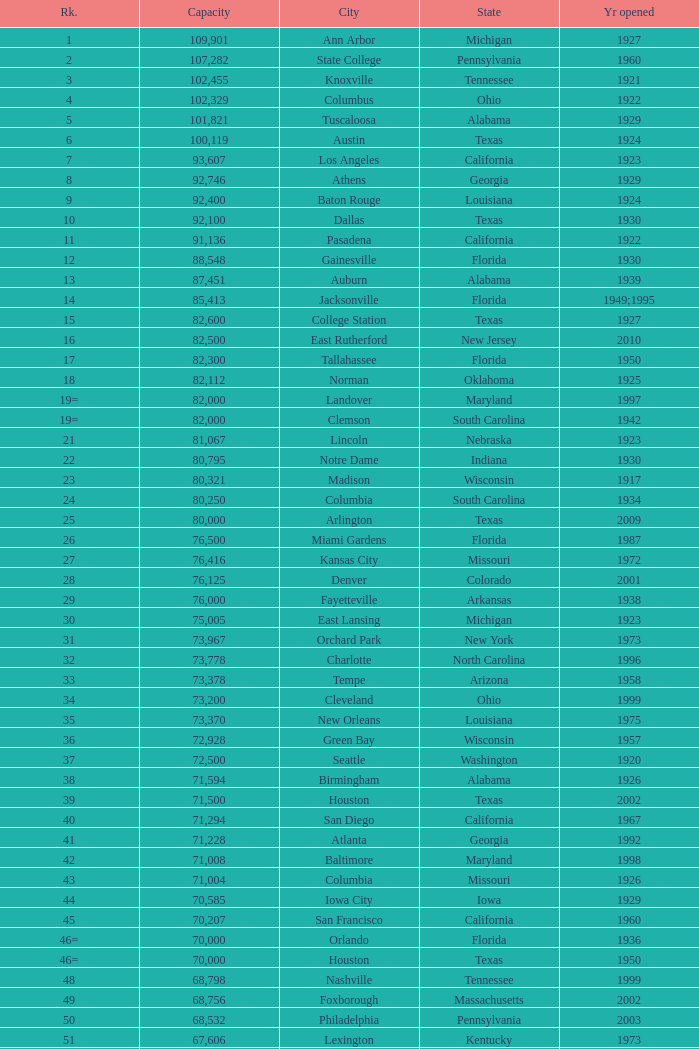Could you parse the entire table? {'header': ['Rk.', 'Capacity', 'City', 'State', 'Yr opened'], 'rows': [['1', '109,901', 'Ann Arbor', 'Michigan', '1927'], ['2', '107,282', 'State College', 'Pennsylvania', '1960'], ['3', '102,455', 'Knoxville', 'Tennessee', '1921'], ['4', '102,329', 'Columbus', 'Ohio', '1922'], ['5', '101,821', 'Tuscaloosa', 'Alabama', '1929'], ['6', '100,119', 'Austin', 'Texas', '1924'], ['7', '93,607', 'Los Angeles', 'California', '1923'], ['8', '92,746', 'Athens', 'Georgia', '1929'], ['9', '92,400', 'Baton Rouge', 'Louisiana', '1924'], ['10', '92,100', 'Dallas', 'Texas', '1930'], ['11', '91,136', 'Pasadena', 'California', '1922'], ['12', '88,548', 'Gainesville', 'Florida', '1930'], ['13', '87,451', 'Auburn', 'Alabama', '1939'], ['14', '85,413', 'Jacksonville', 'Florida', '1949;1995'], ['15', '82,600', 'College Station', 'Texas', '1927'], ['16', '82,500', 'East Rutherford', 'New Jersey', '2010'], ['17', '82,300', 'Tallahassee', 'Florida', '1950'], ['18', '82,112', 'Norman', 'Oklahoma', '1925'], ['19=', '82,000', 'Landover', 'Maryland', '1997'], ['19=', '82,000', 'Clemson', 'South Carolina', '1942'], ['21', '81,067', 'Lincoln', 'Nebraska', '1923'], ['22', '80,795', 'Notre Dame', 'Indiana', '1930'], ['23', '80,321', 'Madison', 'Wisconsin', '1917'], ['24', '80,250', 'Columbia', 'South Carolina', '1934'], ['25', '80,000', 'Arlington', 'Texas', '2009'], ['26', '76,500', 'Miami Gardens', 'Florida', '1987'], ['27', '76,416', 'Kansas City', 'Missouri', '1972'], ['28', '76,125', 'Denver', 'Colorado', '2001'], ['29', '76,000', 'Fayetteville', 'Arkansas', '1938'], ['30', '75,005', 'East Lansing', 'Michigan', '1923'], ['31', '73,967', 'Orchard Park', 'New York', '1973'], ['32', '73,778', 'Charlotte', 'North Carolina', '1996'], ['33', '73,378', 'Tempe', 'Arizona', '1958'], ['34', '73,200', 'Cleveland', 'Ohio', '1999'], ['35', '73,370', 'New Orleans', 'Louisiana', '1975'], ['36', '72,928', 'Green Bay', 'Wisconsin', '1957'], ['37', '72,500', 'Seattle', 'Washington', '1920'], ['38', '71,594', 'Birmingham', 'Alabama', '1926'], ['39', '71,500', 'Houston', 'Texas', '2002'], ['40', '71,294', 'San Diego', 'California', '1967'], ['41', '71,228', 'Atlanta', 'Georgia', '1992'], ['42', '71,008', 'Baltimore', 'Maryland', '1998'], ['43', '71,004', 'Columbia', 'Missouri', '1926'], ['44', '70,585', 'Iowa City', 'Iowa', '1929'], ['45', '70,207', 'San Francisco', 'California', '1960'], ['46=', '70,000', 'Orlando', 'Florida', '1936'], ['46=', '70,000', 'Houston', 'Texas', '1950'], ['48', '68,798', 'Nashville', 'Tennessee', '1999'], ['49', '68,756', 'Foxborough', 'Massachusetts', '2002'], ['50', '68,532', 'Philadelphia', 'Pennsylvania', '2003'], ['51', '67,606', 'Lexington', 'Kentucky', '1973'], ['52', '67,000', 'Seattle', 'Washington', '2002'], ['53', '66,965', 'St. Louis', 'Missouri', '1995'], ['54', '66,233', 'Blacksburg', 'Virginia', '1965'], ['55', '65,857', 'Tampa', 'Florida', '1998'], ['56', '65,790', 'Cincinnati', 'Ohio', '2000'], ['57', '65,050', 'Pittsburgh', 'Pennsylvania', '2001'], ['58=', '65,000', 'San Antonio', 'Texas', '1993'], ['58=', '65,000', 'Detroit', 'Michigan', '2002'], ['60', '64,269', 'New Haven', 'Connecticut', '1914'], ['61', '64,111', 'Minneapolis', 'Minnesota', '1982'], ['62', '64,045', 'Provo', 'Utah', '1964'], ['63', '63,400', 'Glendale', 'Arizona', '2006'], ['64', '63,026', 'Oakland', 'California', '1966'], ['65', '63,000', 'Indianapolis', 'Indiana', '2008'], ['65', '63.000', 'Chapel Hill', 'North Carolina', '1926'], ['66', '62,872', 'Champaign', 'Illinois', '1923'], ['67', '62,717', 'Berkeley', 'California', '1923'], ['68', '61,500', 'Chicago', 'Illinois', '1924;2003'], ['69', '62,500', 'West Lafayette', 'Indiana', '1924'], ['70', '62,380', 'Memphis', 'Tennessee', '1965'], ['71', '61,500', 'Charlottesville', 'Virginia', '1931'], ['72', '61,000', 'Lubbock', 'Texas', '1947'], ['73', '60,580', 'Oxford', 'Mississippi', '1915'], ['74', '60,540', 'Morgantown', 'West Virginia', '1980'], ['75', '60,492', 'Jackson', 'Mississippi', '1941'], ['76', '60,000', 'Stillwater', 'Oklahoma', '1920'], ['78', '57,803', 'Tucson', 'Arizona', '1928'], ['79', '57,583', 'Raleigh', 'North Carolina', '1966'], ['80', '56,692', 'Washington, D.C.', 'District of Columbia', '1961'], ['81=', '56,000', 'Los Angeles', 'California', '1962'], ['81=', '56,000', 'Louisville', 'Kentucky', '1998'], ['83', '55,082', 'Starkville', 'Mississippi', '1914'], ['84=', '55,000', 'Atlanta', 'Georgia', '1913'], ['84=', '55,000', 'Ames', 'Iowa', '1975'], ['86', '53,800', 'Eugene', 'Oregon', '1967'], ['87', '53,750', 'Boulder', 'Colorado', '1924'], ['88', '53,727', 'Little Rock', 'Arkansas', '1948'], ['89', '53,500', 'Bloomington', 'Indiana', '1960'], ['90', '52,593', 'Philadelphia', 'Pennsylvania', '1895'], ['91', '52,480', 'Colorado Springs', 'Colorado', '1962'], ['92', '52,454', 'Piscataway', 'New Jersey', '1994'], ['93', '52,200', 'Manhattan', 'Kansas', '1968'], ['94=', '51,500', 'College Park', 'Maryland', '1950'], ['94=', '51,500', 'El Paso', 'Texas', '1963'], ['96', '50,832', 'Shreveport', 'Louisiana', '1925'], ['97', '50,805', 'Minneapolis', 'Minnesota', '2009'], ['98', '50,445', 'Denver', 'Colorado', '1995'], ['99', '50,291', 'Bronx', 'New York', '2009'], ['100', '50,096', 'Atlanta', 'Georgia', '1996'], ['101', '50,071', 'Lawrence', 'Kansas', '1921'], ['102=', '50,000', 'Honolulu', 'Hawai ʻ i', '1975'], ['102=', '50,000', 'Greenville', 'North Carolina', '1963'], ['102=', '50,000', 'Waco', 'Texas', '1950'], ['102=', '50,000', 'Stanford', 'California', '1921;2006'], ['106', '49,262', 'Syracuse', 'New York', '1980'], ['107', '49,115', 'Arlington', 'Texas', '1994'], ['108', '49,033', 'Phoenix', 'Arizona', '1998'], ['109', '48,876', 'Baltimore', 'Maryland', '1992'], ['110', '47,130', 'Evanston', 'Illinois', '1996'], ['111', '47,116', 'Seattle', 'Washington', '1999'], ['112', '46,861', 'St. Louis', 'Missouri', '2006'], ['113', '45,674', 'Corvallis', 'Oregon', '1953'], ['114', '45,634', 'Salt Lake City', 'Utah', '1998'], ['115', '45,301', 'Orlando', 'Florida', '2007'], ['116', '45,050', 'Anaheim', 'California', '1966'], ['117', '44,500', 'Chestnut Hill', 'Massachusetts', '1957'], ['118', '44,008', 'Fort Worth', 'Texas', '1930'], ['119', '43,647', 'Philadelphia', 'Pennsylvania', '2004'], ['120', '43,545', 'Cleveland', 'Ohio', '1994'], ['121', '42,445', 'San Diego', 'California', '2004'], ['122', '42,059', 'Cincinnati', 'Ohio', '2003'], ['123', '41,900', 'Milwaukee', 'Wisconsin', '2001'], ['124', '41,888', 'Washington, D.C.', 'District of Columbia', '2008'], ['125', '41,800', 'Flushing, New York', 'New York', '2009'], ['126', '41,782', 'Detroit', 'Michigan', '2000'], ['127', '41,503', 'San Francisco', 'California', '2000'], ['128', '41,160', 'Chicago', 'Illinois', '1914'], ['129', '41,031', 'Fresno', 'California', '1980'], ['130', '40,950', 'Houston', 'Texas', '2000'], ['131', '40,646', 'Mobile', 'Alabama', '1948'], ['132', '40,615', 'Chicago', 'Illinois', '1991'], ['133', '40,094', 'Albuquerque', 'New Mexico', '1960'], ['134=', '40,000', 'South Williamsport', 'Pennsylvania', '1959'], ['134=', '40,000', 'East Hartford', 'Connecticut', '2003'], ['134=', '40,000', 'West Point', 'New York', '1924'], ['137', '39,790', 'Nashville', 'Tennessee', '1922'], ['138', '39,504', 'Minneapolis', 'Minnesota', '2010'], ['139', '39,000', 'Kansas City', 'Missouri', '1973'], ['140', '38,496', 'Pittsburgh', 'Pennsylvania', '2001'], ['141', '38,019', 'Huntington', 'West Virginia', '1991'], ['142', '37,402', 'Boston', 'Massachusetts', '1912'], ['143=', '37,000', 'Boise', 'Idaho', '1970'], ['143=', '37,000', 'Miami', 'Florida', '2012'], ['145', '36,973', 'St. Petersburg', 'Florida', '1990'], ['146', '36,800', 'Whitney', 'Nevada', '1971'], ['147', '36,000', 'Hattiesburg', 'Mississippi', '1932'], ['148', '35,117', 'Pullman', 'Washington', '1972'], ['149', '35,097', 'Cincinnati', 'Ohio', '1924'], ['150', '34,400', 'Fort Collins', 'Colorado', '1968'], ['151', '34,000', 'Annapolis', 'Maryland', '1959'], ['152', '33,941', 'Durham', 'North Carolina', '1929'], ['153', '32,580', 'Laramie', 'Wyoming', '1950'], ['154=', '32,000', 'University Park', 'Texas', '2000'], ['154=', '32,000', 'Houston', 'Texas', '1942'], ['156', '31,500', 'Winston-Salem', 'North Carolina', '1968'], ['157=', '31,000', 'Lafayette', 'Louisiana', '1971'], ['157=', '31,000', 'Akron', 'Ohio', '1940'], ['157=', '31,000', 'DeKalb', 'Illinois', '1965'], ['160', '30,964', 'Jonesboro', 'Arkansas', '1974'], ['161', '30,850', 'Denton', 'Texas', '2011'], ['162', '30,600', 'Ruston', 'Louisiana', '1960'], ['163', '30,456', 'San Jose', 'California', '1933'], ['164', '30,427', 'Monroe', 'Louisiana', '1978'], ['165', '30,343', 'Las Cruces', 'New Mexico', '1978'], ['166', '30,323', 'Allston', 'Massachusetts', '1903'], ['167', '30,295', 'Mount Pleasant', 'Michigan', '1972'], ['168=', '30,200', 'Ypsilanti', 'Michigan', '1969'], ['168=', '30,200', 'Kalamazoo', 'Michigan', '1939'], ['168=', '30,000', 'Boca Raton', 'Florida', '2011'], ['168=', '30,000', 'San Marcos', 'Texas', '1981'], ['168=', '30,000', 'Tulsa', 'Oklahoma', '1930'], ['168=', '30,000', 'Akron', 'Ohio', '2009'], ['168=', '30,000', 'Troy', 'Alabama', '1950'], ['168=', '30,000', 'Norfolk', 'Virginia', '1997'], ['176', '29,993', 'Reno', 'Nevada', '1966'], ['177', '29,013', 'Amherst', 'New York', '1993'], ['178', '29,000', 'Baton Rouge', 'Louisiana', '1928'], ['179', '28,646', 'Spokane', 'Washington', '1950'], ['180', '27,800', 'Princeton', 'New Jersey', '1998'], ['181', '27,000', 'Carson', 'California', '2003'], ['182', '26,248', 'Toledo', 'Ohio', '1937'], ['183', '25,600', 'Grambling', 'Louisiana', '1983'], ['184', '25,597', 'Ithaca', 'New York', '1915'], ['185', '25,500', 'Tallahassee', 'Florida', '1957'], ['186', '25,400', 'Muncie', 'Indiana', '1967'], ['187', '25,200', 'Missoula', 'Montana', '1986'], ['188', '25,189', 'Harrison', 'New Jersey', '2010'], ['189', '25,000', 'Kent', 'Ohio', '1969'], ['190', '24,877', 'Harrisonburg', 'Virginia', '1975'], ['191', '24,600', 'Montgomery', 'Alabama', '1922'], ['192', '24,286', 'Oxford', 'Ohio', '1983'], ['193=', '24,000', 'Omaha', 'Nebraska', '2011'], ['193=', '24,000', 'Athens', 'Ohio', '1929'], ['194', '23,724', 'Bowling Green', 'Ohio', '1966'], ['195', '23,500', 'Worcester', 'Massachusetts', '1924'], ['196', '22,500', 'Lorman', 'Mississippi', '1992'], ['197=', '22,000', 'Houston', 'Texas', '2012'], ['197=', '22,000', 'Newark', 'Delaware', '1952'], ['197=', '22,000', 'Bowling Green', 'Kentucky', '1968'], ['197=', '22,000', 'Orangeburg', 'South Carolina', '1955'], ['201', '21,650', 'Boone', 'North Carolina', '1962'], ['202', '21,500', 'Greensboro', 'North Carolina', '1981'], ['203', '21,650', 'Sacramento', 'California', '1969'], ['204=', '21,000', 'Charleston', 'South Carolina', '1946'], ['204=', '21,000', 'Huntsville', 'Alabama', '1996'], ['204=', '21,000', 'Chicago', 'Illinois', '1994'], ['207', '20,668', 'Chattanooga', 'Tennessee', '1997'], ['208', '20,630', 'Youngstown', 'Ohio', '1982'], ['209', '20,500', 'Frisco', 'Texas', '2005'], ['210', '20,455', 'Columbus', 'Ohio', '1999'], ['211', '20,450', 'Fort Lauderdale', 'Florida', '1959'], ['212', '20,438', 'Portland', 'Oregon', '1926'], ['213', '20,311', 'Sacramento, California', 'California', '1928'], ['214', '20,066', 'Detroit, Michigan', 'Michigan', '1979'], ['215', '20,008', 'Sandy', 'Utah', '2008'], ['216=', '20,000', 'Providence', 'Rhode Island', '1925'], ['216=', '20,000', 'Miami', 'Florida', '1995'], ['216=', '20,000', 'Richmond', 'Kentucky', '1969'], ['216=', '20,000', 'Mesquite', 'Texas', '1977'], ['216=', '20,000', 'Canyon', 'Texas', '1959'], ['216=', '20,000', 'Bridgeview', 'Illinois', '2006']]} What is the lowest capacity for 1903? 30323.0. 